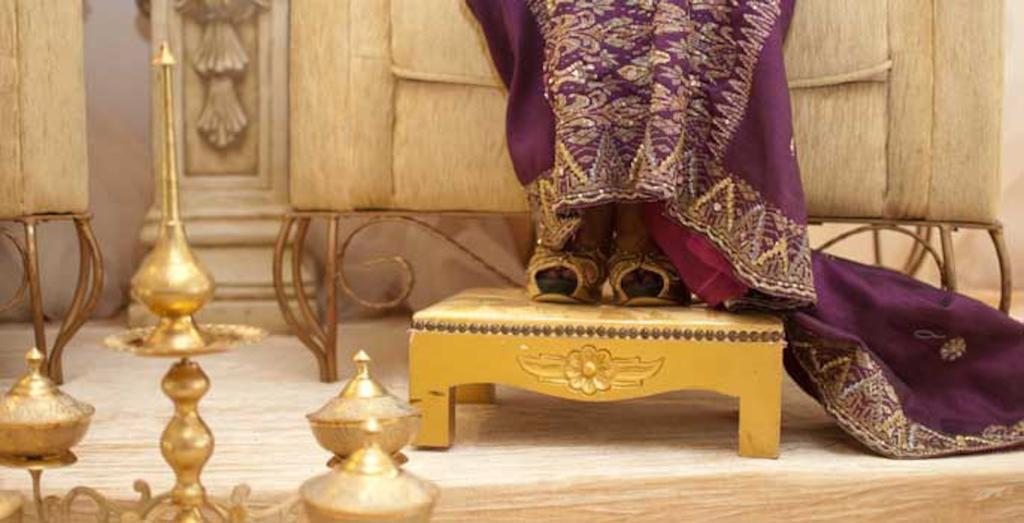What is the person in the image doing? The person is standing on a stool. What else can be seen near the stool? There are objects beside the stool. What can be seen in the background of the image? There is a sofa in the background of the image. What type of butter is being used to grease the station in the image? There is no butter or station present in the image. 